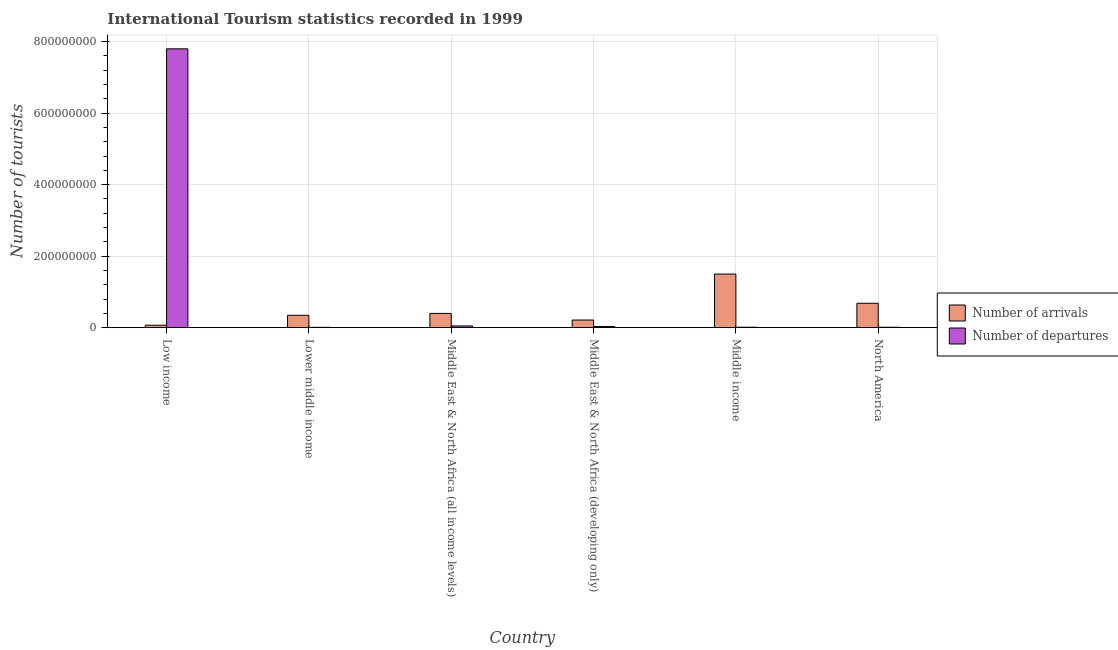Are the number of bars on each tick of the X-axis equal?
Give a very brief answer. Yes. How many bars are there on the 4th tick from the left?
Your answer should be very brief. 2. In how many cases, is the number of bars for a given country not equal to the number of legend labels?
Ensure brevity in your answer.  0. What is the number of tourist departures in Lower middle income?
Ensure brevity in your answer.  9.03e+05. Across all countries, what is the maximum number of tourist arrivals?
Your response must be concise. 1.50e+08. Across all countries, what is the minimum number of tourist departures?
Offer a terse response. 9.03e+05. In which country was the number of tourist departures minimum?
Keep it short and to the point. Lower middle income. What is the total number of tourist arrivals in the graph?
Provide a succinct answer. 3.21e+08. What is the difference between the number of tourist departures in Lower middle income and that in Middle East & North Africa (developing only)?
Provide a succinct answer. -2.31e+06. What is the difference between the number of tourist arrivals in Middle income and the number of tourist departures in North America?
Provide a succinct answer. 1.49e+08. What is the average number of tourist departures per country?
Your answer should be compact. 1.32e+08. What is the difference between the number of tourist departures and number of tourist arrivals in Middle East & North Africa (all income levels)?
Your answer should be very brief. -3.51e+07. In how many countries, is the number of tourist arrivals greater than 520000000 ?
Make the answer very short. 0. What is the ratio of the number of tourist arrivals in Middle East & North Africa (all income levels) to that in North America?
Your answer should be compact. 0.58. Is the number of tourist arrivals in Middle East & North Africa (developing only) less than that in Middle income?
Ensure brevity in your answer.  Yes. Is the difference between the number of tourist departures in Low income and Lower middle income greater than the difference between the number of tourist arrivals in Low income and Lower middle income?
Give a very brief answer. Yes. What is the difference between the highest and the second highest number of tourist departures?
Provide a succinct answer. 7.75e+08. What is the difference between the highest and the lowest number of tourist arrivals?
Your response must be concise. 1.43e+08. In how many countries, is the number of tourist arrivals greater than the average number of tourist arrivals taken over all countries?
Provide a short and direct response. 2. Is the sum of the number of tourist departures in Lower middle income and Middle East & North Africa (all income levels) greater than the maximum number of tourist arrivals across all countries?
Ensure brevity in your answer.  No. What does the 2nd bar from the left in Low income represents?
Your answer should be compact. Number of departures. What does the 1st bar from the right in Middle East & North Africa (all income levels) represents?
Offer a very short reply. Number of departures. How many bars are there?
Make the answer very short. 12. Are all the bars in the graph horizontal?
Keep it short and to the point. No. How many countries are there in the graph?
Make the answer very short. 6. What is the difference between two consecutive major ticks on the Y-axis?
Your answer should be compact. 2.00e+08. Does the graph contain any zero values?
Ensure brevity in your answer.  No. Where does the legend appear in the graph?
Provide a succinct answer. Center right. How are the legend labels stacked?
Provide a succinct answer. Vertical. What is the title of the graph?
Offer a very short reply. International Tourism statistics recorded in 1999. Does "Public credit registry" appear as one of the legend labels in the graph?
Offer a very short reply. No. What is the label or title of the Y-axis?
Provide a short and direct response. Number of tourists. What is the Number of tourists of Number of arrivals in Low income?
Ensure brevity in your answer.  6.82e+06. What is the Number of tourists in Number of departures in Low income?
Make the answer very short. 7.80e+08. What is the Number of tourists of Number of arrivals in Lower middle income?
Your answer should be very brief. 3.47e+07. What is the Number of tourists of Number of departures in Lower middle income?
Offer a terse response. 9.03e+05. What is the Number of tourists of Number of arrivals in Middle East & North Africa (all income levels)?
Give a very brief answer. 3.99e+07. What is the Number of tourists in Number of departures in Middle East & North Africa (all income levels)?
Your response must be concise. 4.79e+06. What is the Number of tourists of Number of arrivals in Middle East & North Africa (developing only)?
Offer a terse response. 2.13e+07. What is the Number of tourists of Number of departures in Middle East & North Africa (developing only)?
Offer a very short reply. 3.21e+06. What is the Number of tourists of Number of arrivals in Middle income?
Offer a very short reply. 1.50e+08. What is the Number of tourists of Number of departures in Middle income?
Keep it short and to the point. 1.20e+06. What is the Number of tourists in Number of arrivals in North America?
Offer a very short reply. 6.83e+07. What is the Number of tourists in Number of departures in North America?
Offer a terse response. 1.10e+06. Across all countries, what is the maximum Number of tourists of Number of arrivals?
Ensure brevity in your answer.  1.50e+08. Across all countries, what is the maximum Number of tourists of Number of departures?
Make the answer very short. 7.80e+08. Across all countries, what is the minimum Number of tourists of Number of arrivals?
Provide a short and direct response. 6.82e+06. Across all countries, what is the minimum Number of tourists of Number of departures?
Your answer should be very brief. 9.03e+05. What is the total Number of tourists of Number of arrivals in the graph?
Offer a very short reply. 3.21e+08. What is the total Number of tourists in Number of departures in the graph?
Offer a terse response. 7.91e+08. What is the difference between the Number of tourists in Number of arrivals in Low income and that in Lower middle income?
Your answer should be compact. -2.78e+07. What is the difference between the Number of tourists of Number of departures in Low income and that in Lower middle income?
Your response must be concise. 7.79e+08. What is the difference between the Number of tourists in Number of arrivals in Low income and that in Middle East & North Africa (all income levels)?
Give a very brief answer. -3.31e+07. What is the difference between the Number of tourists in Number of departures in Low income and that in Middle East & North Africa (all income levels)?
Keep it short and to the point. 7.75e+08. What is the difference between the Number of tourists in Number of arrivals in Low income and that in Middle East & North Africa (developing only)?
Offer a very short reply. -1.45e+07. What is the difference between the Number of tourists of Number of departures in Low income and that in Middle East & North Africa (developing only)?
Your answer should be very brief. 7.77e+08. What is the difference between the Number of tourists of Number of arrivals in Low income and that in Middle income?
Ensure brevity in your answer.  -1.43e+08. What is the difference between the Number of tourists in Number of departures in Low income and that in Middle income?
Make the answer very short. 7.79e+08. What is the difference between the Number of tourists of Number of arrivals in Low income and that in North America?
Your answer should be very brief. -6.15e+07. What is the difference between the Number of tourists in Number of departures in Low income and that in North America?
Offer a very short reply. 7.79e+08. What is the difference between the Number of tourists in Number of arrivals in Lower middle income and that in Middle East & North Africa (all income levels)?
Provide a succinct answer. -5.24e+06. What is the difference between the Number of tourists of Number of departures in Lower middle income and that in Middle East & North Africa (all income levels)?
Provide a succinct answer. -3.88e+06. What is the difference between the Number of tourists of Number of arrivals in Lower middle income and that in Middle East & North Africa (developing only)?
Your response must be concise. 1.33e+07. What is the difference between the Number of tourists of Number of departures in Lower middle income and that in Middle East & North Africa (developing only)?
Provide a succinct answer. -2.31e+06. What is the difference between the Number of tourists in Number of arrivals in Lower middle income and that in Middle income?
Your answer should be compact. -1.15e+08. What is the difference between the Number of tourists of Number of departures in Lower middle income and that in Middle income?
Your response must be concise. -3.01e+05. What is the difference between the Number of tourists in Number of arrivals in Lower middle income and that in North America?
Keep it short and to the point. -3.36e+07. What is the difference between the Number of tourists in Number of departures in Lower middle income and that in North America?
Give a very brief answer. -2.00e+05. What is the difference between the Number of tourists in Number of arrivals in Middle East & North Africa (all income levels) and that in Middle East & North Africa (developing only)?
Make the answer very short. 1.86e+07. What is the difference between the Number of tourists in Number of departures in Middle East & North Africa (all income levels) and that in Middle East & North Africa (developing only)?
Provide a short and direct response. 1.58e+06. What is the difference between the Number of tourists in Number of arrivals in Middle East & North Africa (all income levels) and that in Middle income?
Make the answer very short. -1.10e+08. What is the difference between the Number of tourists in Number of departures in Middle East & North Africa (all income levels) and that in Middle income?
Your answer should be very brief. 3.58e+06. What is the difference between the Number of tourists in Number of arrivals in Middle East & North Africa (all income levels) and that in North America?
Provide a short and direct response. -2.84e+07. What is the difference between the Number of tourists of Number of departures in Middle East & North Africa (all income levels) and that in North America?
Give a very brief answer. 3.68e+06. What is the difference between the Number of tourists of Number of arrivals in Middle East & North Africa (developing only) and that in Middle income?
Your answer should be compact. -1.29e+08. What is the difference between the Number of tourists of Number of departures in Middle East & North Africa (developing only) and that in Middle income?
Your answer should be very brief. 2.01e+06. What is the difference between the Number of tourists of Number of arrivals in Middle East & North Africa (developing only) and that in North America?
Your response must be concise. -4.70e+07. What is the difference between the Number of tourists in Number of departures in Middle East & North Africa (developing only) and that in North America?
Offer a terse response. 2.11e+06. What is the difference between the Number of tourists in Number of arrivals in Middle income and that in North America?
Offer a terse response. 8.17e+07. What is the difference between the Number of tourists in Number of departures in Middle income and that in North America?
Provide a succinct answer. 1.01e+05. What is the difference between the Number of tourists of Number of arrivals in Low income and the Number of tourists of Number of departures in Lower middle income?
Offer a very short reply. 5.92e+06. What is the difference between the Number of tourists of Number of arrivals in Low income and the Number of tourists of Number of departures in Middle East & North Africa (all income levels)?
Your answer should be compact. 2.04e+06. What is the difference between the Number of tourists in Number of arrivals in Low income and the Number of tourists in Number of departures in Middle East & North Africa (developing only)?
Make the answer very short. 3.61e+06. What is the difference between the Number of tourists of Number of arrivals in Low income and the Number of tourists of Number of departures in Middle income?
Ensure brevity in your answer.  5.62e+06. What is the difference between the Number of tourists in Number of arrivals in Low income and the Number of tourists in Number of departures in North America?
Your answer should be very brief. 5.72e+06. What is the difference between the Number of tourists of Number of arrivals in Lower middle income and the Number of tourists of Number of departures in Middle East & North Africa (all income levels)?
Provide a short and direct response. 2.99e+07. What is the difference between the Number of tourists in Number of arrivals in Lower middle income and the Number of tourists in Number of departures in Middle East & North Africa (developing only)?
Provide a short and direct response. 3.14e+07. What is the difference between the Number of tourists of Number of arrivals in Lower middle income and the Number of tourists of Number of departures in Middle income?
Give a very brief answer. 3.34e+07. What is the difference between the Number of tourists of Number of arrivals in Lower middle income and the Number of tourists of Number of departures in North America?
Offer a terse response. 3.36e+07. What is the difference between the Number of tourists in Number of arrivals in Middle East & North Africa (all income levels) and the Number of tourists in Number of departures in Middle East & North Africa (developing only)?
Your response must be concise. 3.67e+07. What is the difference between the Number of tourists in Number of arrivals in Middle East & North Africa (all income levels) and the Number of tourists in Number of departures in Middle income?
Give a very brief answer. 3.87e+07. What is the difference between the Number of tourists of Number of arrivals in Middle East & North Africa (all income levels) and the Number of tourists of Number of departures in North America?
Keep it short and to the point. 3.88e+07. What is the difference between the Number of tourists in Number of arrivals in Middle East & North Africa (developing only) and the Number of tourists in Number of departures in Middle income?
Your answer should be very brief. 2.01e+07. What is the difference between the Number of tourists of Number of arrivals in Middle East & North Africa (developing only) and the Number of tourists of Number of departures in North America?
Provide a succinct answer. 2.02e+07. What is the difference between the Number of tourists in Number of arrivals in Middle income and the Number of tourists in Number of departures in North America?
Your answer should be very brief. 1.49e+08. What is the average Number of tourists in Number of arrivals per country?
Give a very brief answer. 5.35e+07. What is the average Number of tourists of Number of departures per country?
Your response must be concise. 1.32e+08. What is the difference between the Number of tourists of Number of arrivals and Number of tourists of Number of departures in Low income?
Your answer should be compact. -7.73e+08. What is the difference between the Number of tourists in Number of arrivals and Number of tourists in Number of departures in Lower middle income?
Make the answer very short. 3.38e+07. What is the difference between the Number of tourists in Number of arrivals and Number of tourists in Number of departures in Middle East & North Africa (all income levels)?
Your response must be concise. 3.51e+07. What is the difference between the Number of tourists of Number of arrivals and Number of tourists of Number of departures in Middle East & North Africa (developing only)?
Your response must be concise. 1.81e+07. What is the difference between the Number of tourists in Number of arrivals and Number of tourists in Number of departures in Middle income?
Offer a very short reply. 1.49e+08. What is the difference between the Number of tourists of Number of arrivals and Number of tourists of Number of departures in North America?
Offer a terse response. 6.72e+07. What is the ratio of the Number of tourists of Number of arrivals in Low income to that in Lower middle income?
Offer a terse response. 0.2. What is the ratio of the Number of tourists in Number of departures in Low income to that in Lower middle income?
Your answer should be very brief. 863.75. What is the ratio of the Number of tourists of Number of arrivals in Low income to that in Middle East & North Africa (all income levels)?
Make the answer very short. 0.17. What is the ratio of the Number of tourists in Number of departures in Low income to that in Middle East & North Africa (all income levels)?
Offer a terse response. 162.97. What is the ratio of the Number of tourists of Number of arrivals in Low income to that in Middle East & North Africa (developing only)?
Provide a succinct answer. 0.32. What is the ratio of the Number of tourists in Number of departures in Low income to that in Middle East & North Africa (developing only)?
Provide a succinct answer. 242.98. What is the ratio of the Number of tourists in Number of arrivals in Low income to that in Middle income?
Provide a short and direct response. 0.05. What is the ratio of the Number of tourists in Number of departures in Low income to that in Middle income?
Your answer should be compact. 647.81. What is the ratio of the Number of tourists of Number of arrivals in Low income to that in North America?
Provide a succinct answer. 0.1. What is the ratio of the Number of tourists of Number of departures in Low income to that in North America?
Your answer should be compact. 707.13. What is the ratio of the Number of tourists in Number of arrivals in Lower middle income to that in Middle East & North Africa (all income levels)?
Offer a very short reply. 0.87. What is the ratio of the Number of tourists in Number of departures in Lower middle income to that in Middle East & North Africa (all income levels)?
Provide a short and direct response. 0.19. What is the ratio of the Number of tourists of Number of arrivals in Lower middle income to that in Middle East & North Africa (developing only)?
Give a very brief answer. 1.63. What is the ratio of the Number of tourists in Number of departures in Lower middle income to that in Middle East & North Africa (developing only)?
Provide a short and direct response. 0.28. What is the ratio of the Number of tourists of Number of arrivals in Lower middle income to that in Middle income?
Give a very brief answer. 0.23. What is the ratio of the Number of tourists of Number of arrivals in Lower middle income to that in North America?
Provide a succinct answer. 0.51. What is the ratio of the Number of tourists of Number of departures in Lower middle income to that in North America?
Your response must be concise. 0.82. What is the ratio of the Number of tourists in Number of arrivals in Middle East & North Africa (all income levels) to that in Middle East & North Africa (developing only)?
Provide a short and direct response. 1.87. What is the ratio of the Number of tourists in Number of departures in Middle East & North Africa (all income levels) to that in Middle East & North Africa (developing only)?
Your answer should be very brief. 1.49. What is the ratio of the Number of tourists in Number of arrivals in Middle East & North Africa (all income levels) to that in Middle income?
Provide a short and direct response. 0.27. What is the ratio of the Number of tourists in Number of departures in Middle East & North Africa (all income levels) to that in Middle income?
Ensure brevity in your answer.  3.98. What is the ratio of the Number of tourists of Number of arrivals in Middle East & North Africa (all income levels) to that in North America?
Provide a short and direct response. 0.58. What is the ratio of the Number of tourists in Number of departures in Middle East & North Africa (all income levels) to that in North America?
Make the answer very short. 4.34. What is the ratio of the Number of tourists in Number of arrivals in Middle East & North Africa (developing only) to that in Middle income?
Make the answer very short. 0.14. What is the ratio of the Number of tourists in Number of departures in Middle East & North Africa (developing only) to that in Middle income?
Your answer should be very brief. 2.67. What is the ratio of the Number of tourists of Number of arrivals in Middle East & North Africa (developing only) to that in North America?
Provide a short and direct response. 0.31. What is the ratio of the Number of tourists in Number of departures in Middle East & North Africa (developing only) to that in North America?
Your answer should be compact. 2.91. What is the ratio of the Number of tourists of Number of arrivals in Middle income to that in North America?
Make the answer very short. 2.2. What is the ratio of the Number of tourists of Number of departures in Middle income to that in North America?
Offer a very short reply. 1.09. What is the difference between the highest and the second highest Number of tourists in Number of arrivals?
Your response must be concise. 8.17e+07. What is the difference between the highest and the second highest Number of tourists in Number of departures?
Ensure brevity in your answer.  7.75e+08. What is the difference between the highest and the lowest Number of tourists in Number of arrivals?
Offer a terse response. 1.43e+08. What is the difference between the highest and the lowest Number of tourists of Number of departures?
Your answer should be very brief. 7.79e+08. 